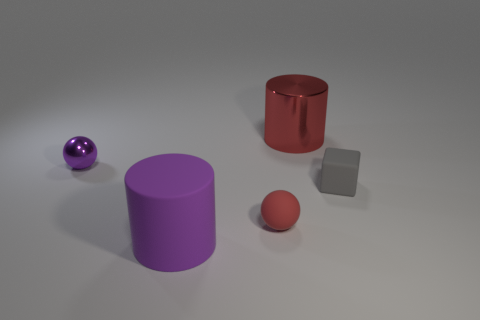Add 1 metallic cylinders. How many objects exist? 6 Subtract all purple spheres. How many spheres are left? 1 Subtract 1 spheres. How many spheres are left? 1 Add 2 large red objects. How many large red objects are left? 3 Add 3 big purple metal objects. How many big purple metal objects exist? 3 Subtract 0 blue cylinders. How many objects are left? 5 Subtract all cylinders. How many objects are left? 3 Subtract all purple cylinders. Subtract all gray cubes. How many cylinders are left? 1 Subtract all purple objects. Subtract all red cylinders. How many objects are left? 2 